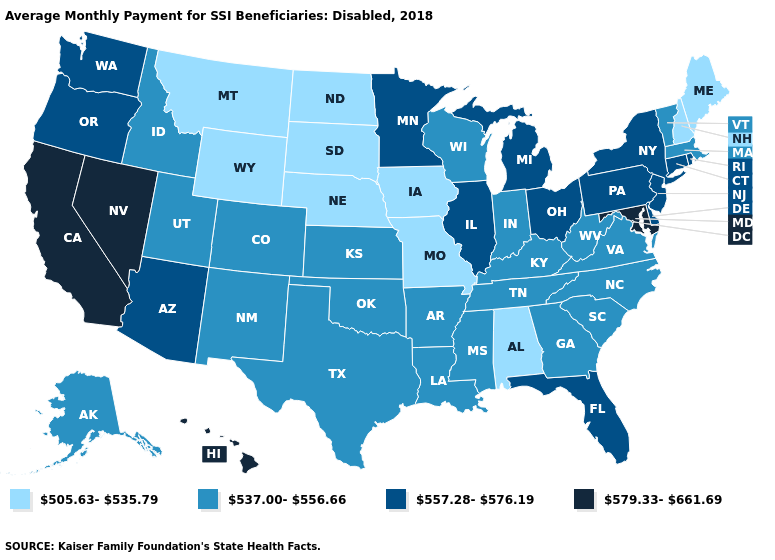What is the highest value in the West ?
Answer briefly. 579.33-661.69. What is the highest value in the USA?
Keep it brief. 579.33-661.69. Among the states that border Connecticut , which have the highest value?
Be succinct. New York, Rhode Island. Does Illinois have the highest value in the MidWest?
Concise answer only. Yes. What is the value of North Dakota?
Quick response, please. 505.63-535.79. How many symbols are there in the legend?
Give a very brief answer. 4. What is the value of Arizona?
Write a very short answer. 557.28-576.19. Does New Mexico have a higher value than Georgia?
Be succinct. No. Among the states that border Ohio , which have the lowest value?
Keep it brief. Indiana, Kentucky, West Virginia. Name the states that have a value in the range 579.33-661.69?
Short answer required. California, Hawaii, Maryland, Nevada. What is the value of Rhode Island?
Keep it brief. 557.28-576.19. Among the states that border Wyoming , does Montana have the highest value?
Answer briefly. No. Name the states that have a value in the range 557.28-576.19?
Keep it brief. Arizona, Connecticut, Delaware, Florida, Illinois, Michigan, Minnesota, New Jersey, New York, Ohio, Oregon, Pennsylvania, Rhode Island, Washington. Which states have the lowest value in the USA?
Keep it brief. Alabama, Iowa, Maine, Missouri, Montana, Nebraska, New Hampshire, North Dakota, South Dakota, Wyoming. Name the states that have a value in the range 557.28-576.19?
Be succinct. Arizona, Connecticut, Delaware, Florida, Illinois, Michigan, Minnesota, New Jersey, New York, Ohio, Oregon, Pennsylvania, Rhode Island, Washington. 